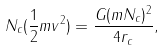Convert formula to latex. <formula><loc_0><loc_0><loc_500><loc_500>N _ { c } ( \frac { 1 } { 2 } m v ^ { 2 } ) = \frac { G ( m N _ { c } ) ^ { 2 } } { 4 r _ { c } } ,</formula> 